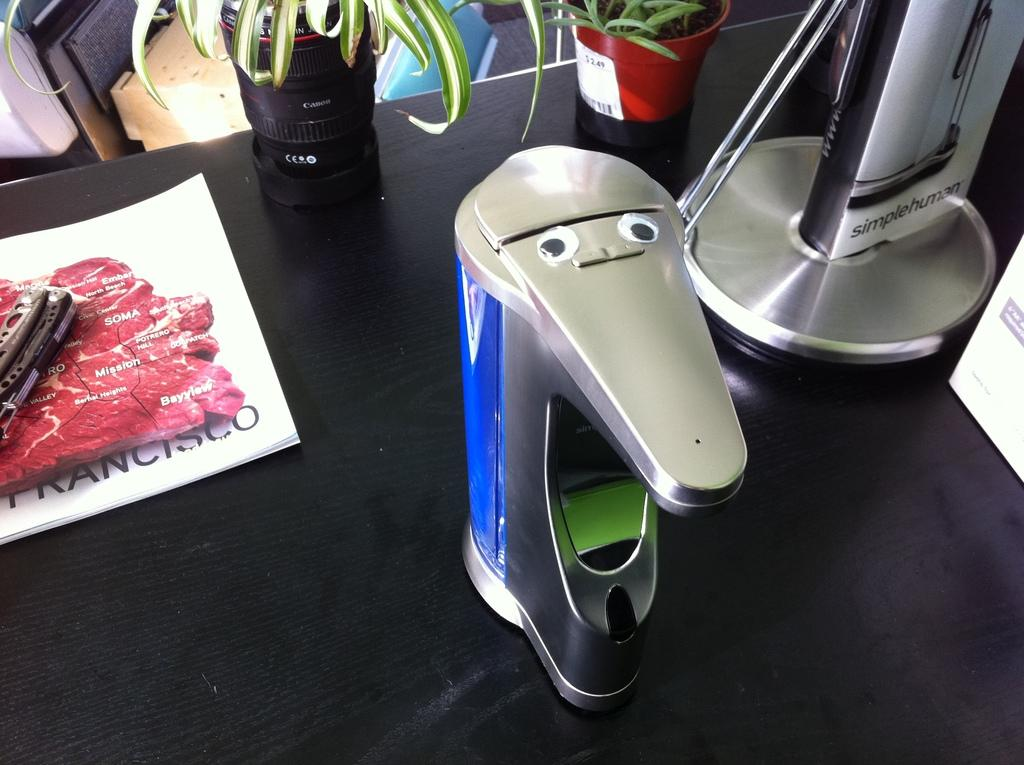Provide a one-sentence caption for the provided image. A single serve coffee maker has googly eyes and sits on a desk by a piece of paper showing the word Francisco. 